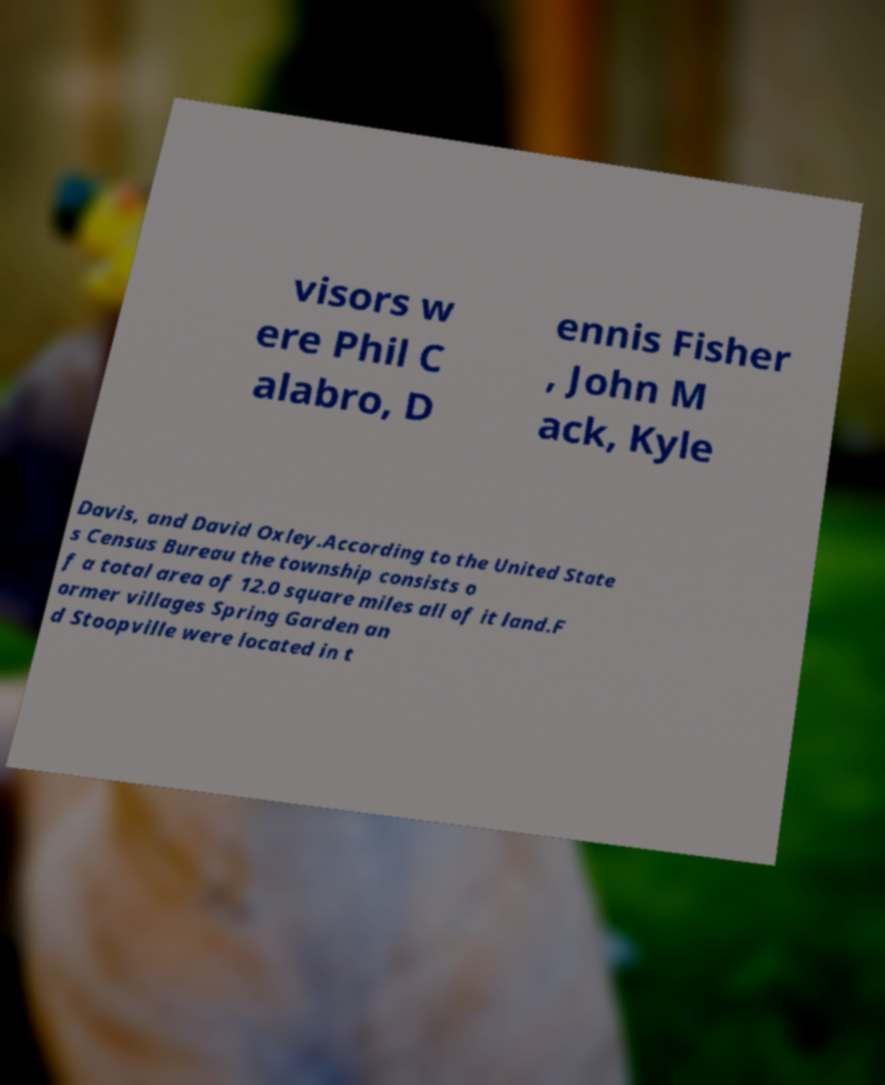Please identify and transcribe the text found in this image. visors w ere Phil C alabro, D ennis Fisher , John M ack, Kyle Davis, and David Oxley.According to the United State s Census Bureau the township consists o f a total area of 12.0 square miles all of it land.F ormer villages Spring Garden an d Stoopville were located in t 